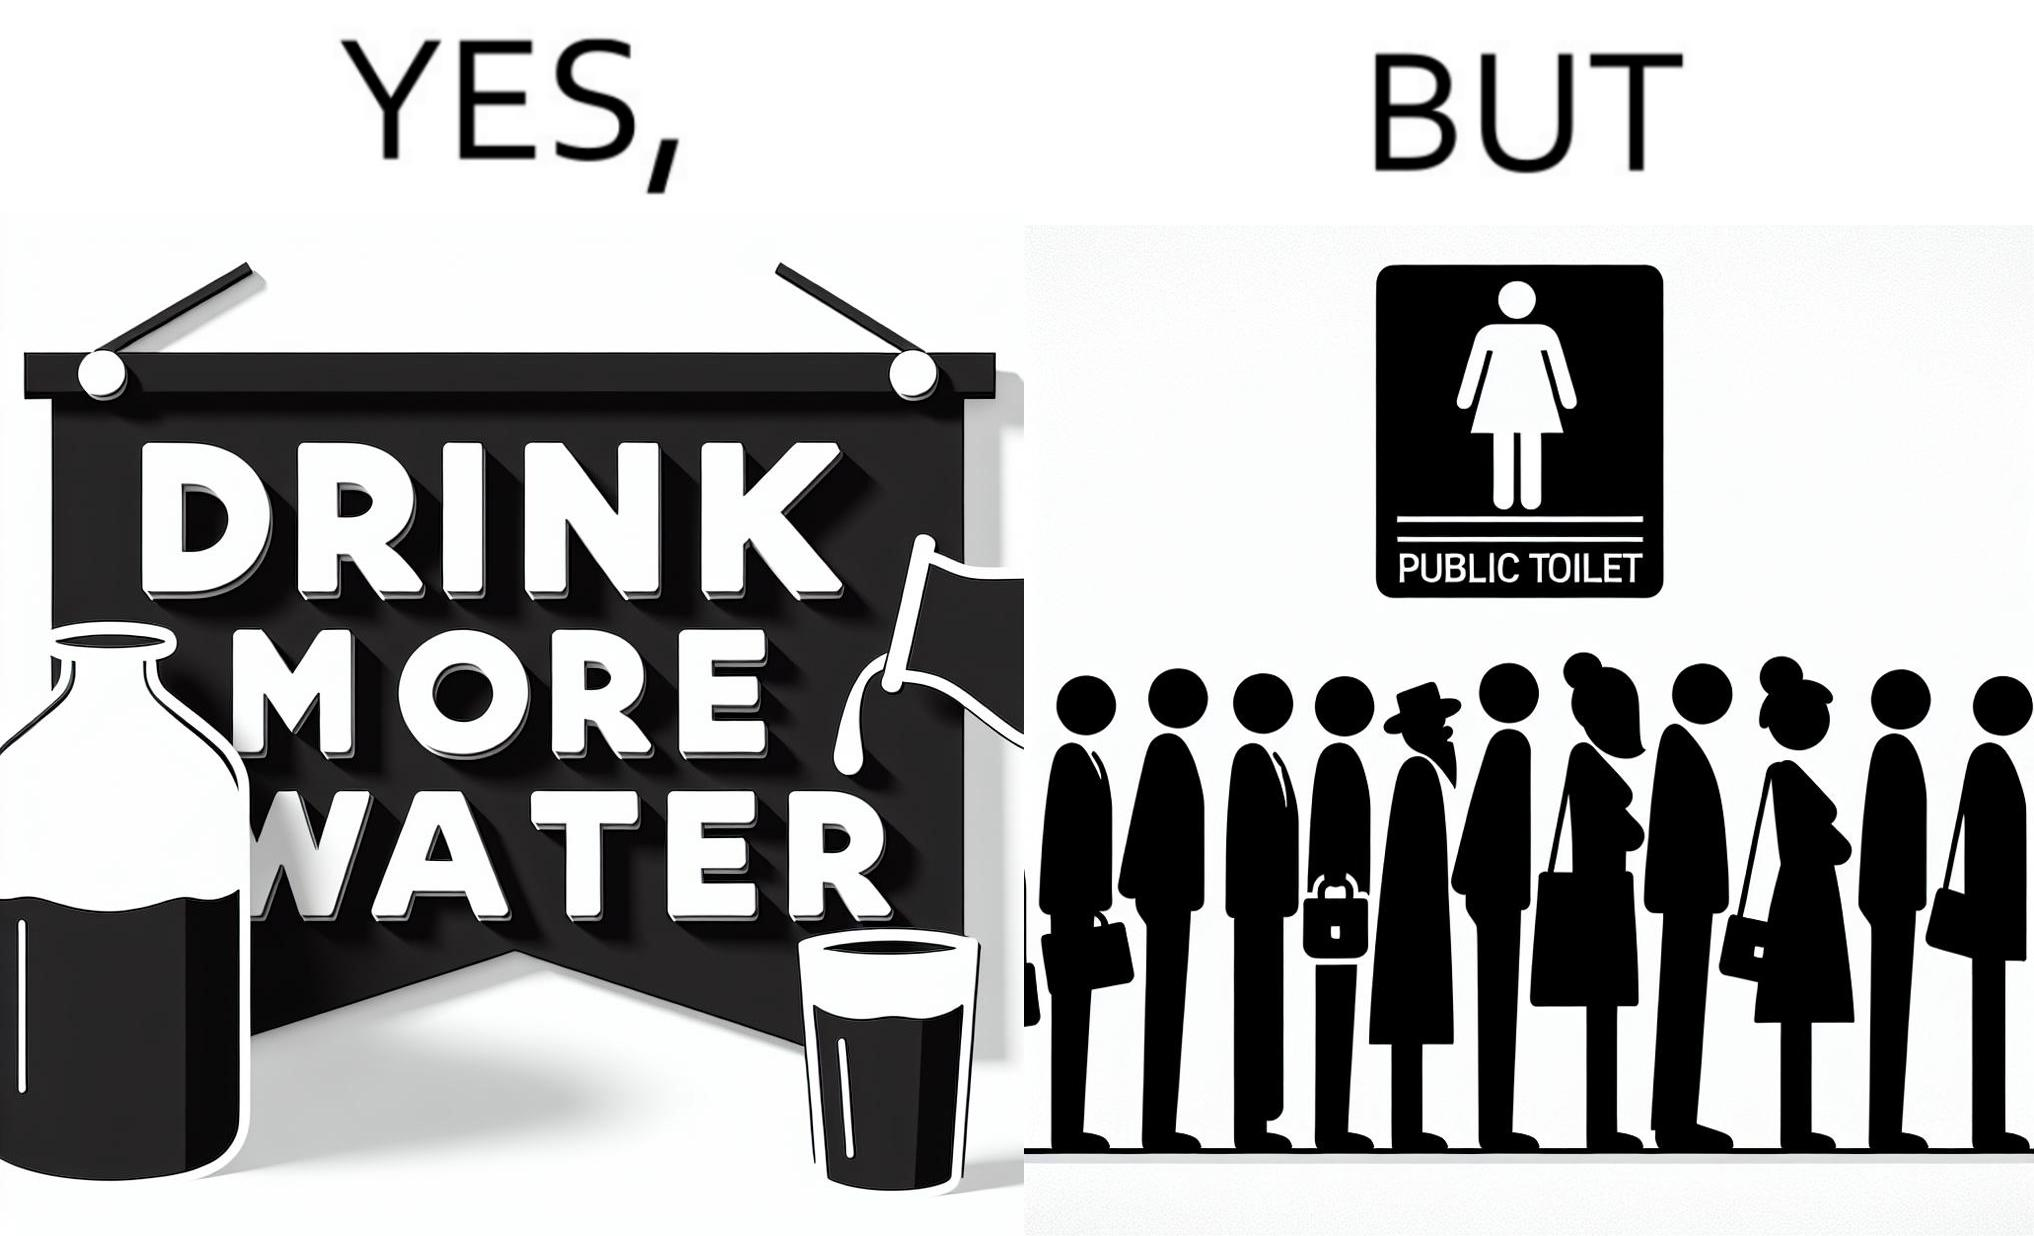Describe the content of this image. The image is ironical, as the message "Drink more water" is meant to improve health, but in turn, it would lead to longer queues in front of public toilets, leading to people holding urine for longer periods, in turn leading to deterioration in health. 